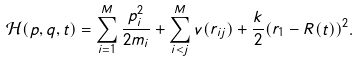<formula> <loc_0><loc_0><loc_500><loc_500>\mathcal { H } ( p , q , t ) = \sum _ { i = 1 } ^ { M } \frac { { p } _ { i } ^ { 2 } } { 2 m _ { i } } + \sum _ { i < j } ^ { M } v ( r _ { i j } ) + \frac { k } { 2 } ( { r } _ { 1 } - { R } ( t ) ) ^ { 2 } .</formula> 